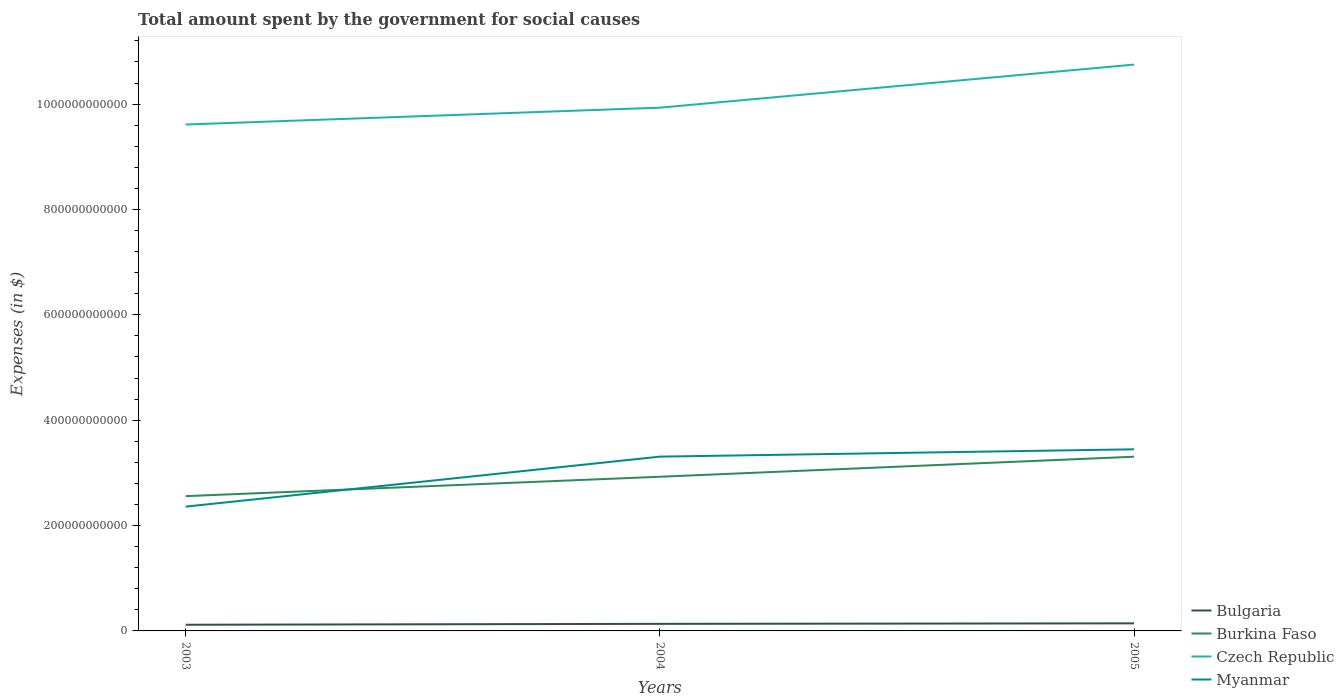How many different coloured lines are there?
Your answer should be compact. 4. Does the line corresponding to Bulgaria intersect with the line corresponding to Burkina Faso?
Your answer should be very brief. No. Across all years, what is the maximum amount spent for social causes by the government in Burkina Faso?
Your answer should be very brief. 2.56e+11. What is the total amount spent for social causes by the government in Burkina Faso in the graph?
Your response must be concise. -3.68e+1. What is the difference between the highest and the second highest amount spent for social causes by the government in Burkina Faso?
Give a very brief answer. 7.48e+1. How many lines are there?
Give a very brief answer. 4. What is the difference between two consecutive major ticks on the Y-axis?
Keep it short and to the point. 2.00e+11. Are the values on the major ticks of Y-axis written in scientific E-notation?
Your response must be concise. No. What is the title of the graph?
Provide a succinct answer. Total amount spent by the government for social causes. What is the label or title of the X-axis?
Offer a terse response. Years. What is the label or title of the Y-axis?
Your answer should be compact. Expenses (in $). What is the Expenses (in $) in Bulgaria in 2003?
Your response must be concise. 1.17e+1. What is the Expenses (in $) in Burkina Faso in 2003?
Make the answer very short. 2.56e+11. What is the Expenses (in $) of Czech Republic in 2003?
Your answer should be very brief. 9.61e+11. What is the Expenses (in $) in Myanmar in 2003?
Your answer should be very brief. 2.36e+11. What is the Expenses (in $) in Bulgaria in 2004?
Your answer should be very brief. 1.34e+1. What is the Expenses (in $) in Burkina Faso in 2004?
Ensure brevity in your answer.  2.93e+11. What is the Expenses (in $) of Czech Republic in 2004?
Offer a very short reply. 9.93e+11. What is the Expenses (in $) in Myanmar in 2004?
Offer a terse response. 3.31e+11. What is the Expenses (in $) of Bulgaria in 2005?
Your answer should be compact. 1.44e+1. What is the Expenses (in $) in Burkina Faso in 2005?
Make the answer very short. 3.31e+11. What is the Expenses (in $) of Czech Republic in 2005?
Provide a succinct answer. 1.08e+12. What is the Expenses (in $) of Myanmar in 2005?
Offer a very short reply. 3.45e+11. Across all years, what is the maximum Expenses (in $) in Bulgaria?
Offer a terse response. 1.44e+1. Across all years, what is the maximum Expenses (in $) of Burkina Faso?
Your answer should be compact. 3.31e+11. Across all years, what is the maximum Expenses (in $) of Czech Republic?
Provide a succinct answer. 1.08e+12. Across all years, what is the maximum Expenses (in $) of Myanmar?
Provide a succinct answer. 3.45e+11. Across all years, what is the minimum Expenses (in $) of Bulgaria?
Offer a very short reply. 1.17e+1. Across all years, what is the minimum Expenses (in $) of Burkina Faso?
Your answer should be very brief. 2.56e+11. Across all years, what is the minimum Expenses (in $) of Czech Republic?
Make the answer very short. 9.61e+11. Across all years, what is the minimum Expenses (in $) in Myanmar?
Make the answer very short. 2.36e+11. What is the total Expenses (in $) of Bulgaria in the graph?
Your answer should be compact. 3.95e+1. What is the total Expenses (in $) in Burkina Faso in the graph?
Offer a very short reply. 8.79e+11. What is the total Expenses (in $) in Czech Republic in the graph?
Provide a short and direct response. 3.03e+12. What is the total Expenses (in $) in Myanmar in the graph?
Give a very brief answer. 9.12e+11. What is the difference between the Expenses (in $) of Bulgaria in 2003 and that in 2004?
Keep it short and to the point. -1.72e+09. What is the difference between the Expenses (in $) of Burkina Faso in 2003 and that in 2004?
Provide a succinct answer. -3.68e+1. What is the difference between the Expenses (in $) in Czech Republic in 2003 and that in 2004?
Keep it short and to the point. -3.20e+1. What is the difference between the Expenses (in $) of Myanmar in 2003 and that in 2004?
Offer a very short reply. -9.49e+1. What is the difference between the Expenses (in $) of Bulgaria in 2003 and that in 2005?
Your answer should be very brief. -2.68e+09. What is the difference between the Expenses (in $) of Burkina Faso in 2003 and that in 2005?
Give a very brief answer. -7.48e+1. What is the difference between the Expenses (in $) of Czech Republic in 2003 and that in 2005?
Provide a succinct answer. -1.14e+11. What is the difference between the Expenses (in $) in Myanmar in 2003 and that in 2005?
Provide a short and direct response. -1.09e+11. What is the difference between the Expenses (in $) of Bulgaria in 2004 and that in 2005?
Offer a terse response. -9.70e+08. What is the difference between the Expenses (in $) in Burkina Faso in 2004 and that in 2005?
Make the answer very short. -3.80e+1. What is the difference between the Expenses (in $) in Czech Republic in 2004 and that in 2005?
Your response must be concise. -8.18e+1. What is the difference between the Expenses (in $) of Myanmar in 2004 and that in 2005?
Offer a very short reply. -1.39e+1. What is the difference between the Expenses (in $) of Bulgaria in 2003 and the Expenses (in $) of Burkina Faso in 2004?
Keep it short and to the point. -2.81e+11. What is the difference between the Expenses (in $) of Bulgaria in 2003 and the Expenses (in $) of Czech Republic in 2004?
Make the answer very short. -9.82e+11. What is the difference between the Expenses (in $) in Bulgaria in 2003 and the Expenses (in $) in Myanmar in 2004?
Make the answer very short. -3.19e+11. What is the difference between the Expenses (in $) of Burkina Faso in 2003 and the Expenses (in $) of Czech Republic in 2004?
Provide a succinct answer. -7.37e+11. What is the difference between the Expenses (in $) of Burkina Faso in 2003 and the Expenses (in $) of Myanmar in 2004?
Ensure brevity in your answer.  -7.50e+1. What is the difference between the Expenses (in $) in Czech Republic in 2003 and the Expenses (in $) in Myanmar in 2004?
Keep it short and to the point. 6.30e+11. What is the difference between the Expenses (in $) in Bulgaria in 2003 and the Expenses (in $) in Burkina Faso in 2005?
Your response must be concise. -3.19e+11. What is the difference between the Expenses (in $) in Bulgaria in 2003 and the Expenses (in $) in Czech Republic in 2005?
Provide a succinct answer. -1.06e+12. What is the difference between the Expenses (in $) of Bulgaria in 2003 and the Expenses (in $) of Myanmar in 2005?
Make the answer very short. -3.33e+11. What is the difference between the Expenses (in $) in Burkina Faso in 2003 and the Expenses (in $) in Czech Republic in 2005?
Provide a short and direct response. -8.19e+11. What is the difference between the Expenses (in $) of Burkina Faso in 2003 and the Expenses (in $) of Myanmar in 2005?
Provide a short and direct response. -8.89e+1. What is the difference between the Expenses (in $) of Czech Republic in 2003 and the Expenses (in $) of Myanmar in 2005?
Ensure brevity in your answer.  6.16e+11. What is the difference between the Expenses (in $) of Bulgaria in 2004 and the Expenses (in $) of Burkina Faso in 2005?
Keep it short and to the point. -3.17e+11. What is the difference between the Expenses (in $) of Bulgaria in 2004 and the Expenses (in $) of Czech Republic in 2005?
Offer a terse response. -1.06e+12. What is the difference between the Expenses (in $) in Bulgaria in 2004 and the Expenses (in $) in Myanmar in 2005?
Give a very brief answer. -3.31e+11. What is the difference between the Expenses (in $) of Burkina Faso in 2004 and the Expenses (in $) of Czech Republic in 2005?
Your answer should be very brief. -7.82e+11. What is the difference between the Expenses (in $) of Burkina Faso in 2004 and the Expenses (in $) of Myanmar in 2005?
Give a very brief answer. -5.21e+1. What is the difference between the Expenses (in $) in Czech Republic in 2004 and the Expenses (in $) in Myanmar in 2005?
Ensure brevity in your answer.  6.48e+11. What is the average Expenses (in $) in Bulgaria per year?
Provide a succinct answer. 1.32e+1. What is the average Expenses (in $) of Burkina Faso per year?
Your answer should be compact. 2.93e+11. What is the average Expenses (in $) in Czech Republic per year?
Your answer should be very brief. 1.01e+12. What is the average Expenses (in $) in Myanmar per year?
Ensure brevity in your answer.  3.04e+11. In the year 2003, what is the difference between the Expenses (in $) of Bulgaria and Expenses (in $) of Burkina Faso?
Keep it short and to the point. -2.44e+11. In the year 2003, what is the difference between the Expenses (in $) in Bulgaria and Expenses (in $) in Czech Republic?
Provide a succinct answer. -9.50e+11. In the year 2003, what is the difference between the Expenses (in $) in Bulgaria and Expenses (in $) in Myanmar?
Make the answer very short. -2.24e+11. In the year 2003, what is the difference between the Expenses (in $) of Burkina Faso and Expenses (in $) of Czech Republic?
Give a very brief answer. -7.05e+11. In the year 2003, what is the difference between the Expenses (in $) in Burkina Faso and Expenses (in $) in Myanmar?
Offer a very short reply. 1.99e+1. In the year 2003, what is the difference between the Expenses (in $) in Czech Republic and Expenses (in $) in Myanmar?
Give a very brief answer. 7.25e+11. In the year 2004, what is the difference between the Expenses (in $) of Bulgaria and Expenses (in $) of Burkina Faso?
Make the answer very short. -2.79e+11. In the year 2004, what is the difference between the Expenses (in $) of Bulgaria and Expenses (in $) of Czech Republic?
Provide a succinct answer. -9.80e+11. In the year 2004, what is the difference between the Expenses (in $) in Bulgaria and Expenses (in $) in Myanmar?
Your answer should be very brief. -3.17e+11. In the year 2004, what is the difference between the Expenses (in $) in Burkina Faso and Expenses (in $) in Czech Republic?
Your answer should be very brief. -7.01e+11. In the year 2004, what is the difference between the Expenses (in $) in Burkina Faso and Expenses (in $) in Myanmar?
Provide a succinct answer. -3.82e+1. In the year 2004, what is the difference between the Expenses (in $) of Czech Republic and Expenses (in $) of Myanmar?
Keep it short and to the point. 6.62e+11. In the year 2005, what is the difference between the Expenses (in $) of Bulgaria and Expenses (in $) of Burkina Faso?
Keep it short and to the point. -3.16e+11. In the year 2005, what is the difference between the Expenses (in $) of Bulgaria and Expenses (in $) of Czech Republic?
Provide a succinct answer. -1.06e+12. In the year 2005, what is the difference between the Expenses (in $) in Bulgaria and Expenses (in $) in Myanmar?
Make the answer very short. -3.30e+11. In the year 2005, what is the difference between the Expenses (in $) of Burkina Faso and Expenses (in $) of Czech Republic?
Offer a terse response. -7.44e+11. In the year 2005, what is the difference between the Expenses (in $) in Burkina Faso and Expenses (in $) in Myanmar?
Your response must be concise. -1.41e+1. In the year 2005, what is the difference between the Expenses (in $) in Czech Republic and Expenses (in $) in Myanmar?
Provide a succinct answer. 7.30e+11. What is the ratio of the Expenses (in $) in Bulgaria in 2003 to that in 2004?
Give a very brief answer. 0.87. What is the ratio of the Expenses (in $) in Burkina Faso in 2003 to that in 2004?
Offer a terse response. 0.87. What is the ratio of the Expenses (in $) of Czech Republic in 2003 to that in 2004?
Provide a short and direct response. 0.97. What is the ratio of the Expenses (in $) of Myanmar in 2003 to that in 2004?
Provide a succinct answer. 0.71. What is the ratio of the Expenses (in $) in Bulgaria in 2003 to that in 2005?
Make the answer very short. 0.81. What is the ratio of the Expenses (in $) in Burkina Faso in 2003 to that in 2005?
Keep it short and to the point. 0.77. What is the ratio of the Expenses (in $) in Czech Republic in 2003 to that in 2005?
Give a very brief answer. 0.89. What is the ratio of the Expenses (in $) of Myanmar in 2003 to that in 2005?
Ensure brevity in your answer.  0.68. What is the ratio of the Expenses (in $) of Bulgaria in 2004 to that in 2005?
Give a very brief answer. 0.93. What is the ratio of the Expenses (in $) in Burkina Faso in 2004 to that in 2005?
Ensure brevity in your answer.  0.89. What is the ratio of the Expenses (in $) in Czech Republic in 2004 to that in 2005?
Offer a very short reply. 0.92. What is the ratio of the Expenses (in $) of Myanmar in 2004 to that in 2005?
Provide a succinct answer. 0.96. What is the difference between the highest and the second highest Expenses (in $) in Bulgaria?
Provide a short and direct response. 9.70e+08. What is the difference between the highest and the second highest Expenses (in $) of Burkina Faso?
Offer a terse response. 3.80e+1. What is the difference between the highest and the second highest Expenses (in $) of Czech Republic?
Your response must be concise. 8.18e+1. What is the difference between the highest and the second highest Expenses (in $) of Myanmar?
Ensure brevity in your answer.  1.39e+1. What is the difference between the highest and the lowest Expenses (in $) of Bulgaria?
Ensure brevity in your answer.  2.68e+09. What is the difference between the highest and the lowest Expenses (in $) of Burkina Faso?
Provide a succinct answer. 7.48e+1. What is the difference between the highest and the lowest Expenses (in $) in Czech Republic?
Ensure brevity in your answer.  1.14e+11. What is the difference between the highest and the lowest Expenses (in $) in Myanmar?
Your response must be concise. 1.09e+11. 